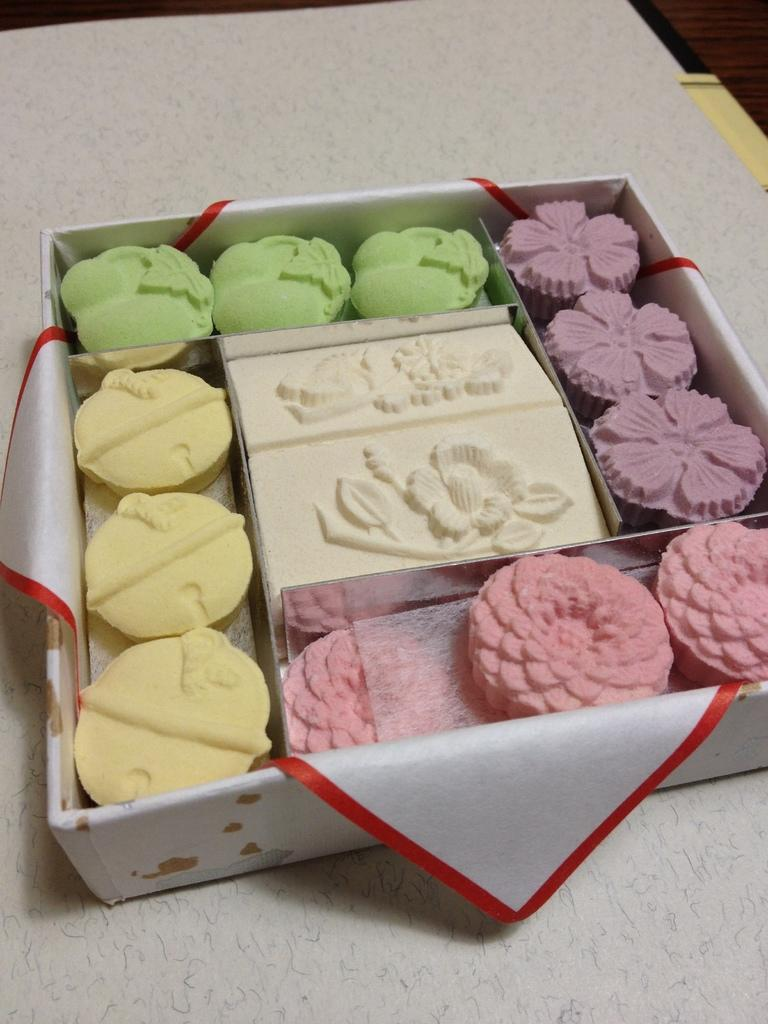What is the main piece of furniture in the image? There is a table in the image. What is placed on the table? There is a box on the table. What is inside the box? The box contains desserts. Is there any paper on the table? Yes, there is a paper on the table. Can you hear the sound of a bone breaking in the image? There is no mention of a bone or any sound in the image, so it cannot be determined from the image. 